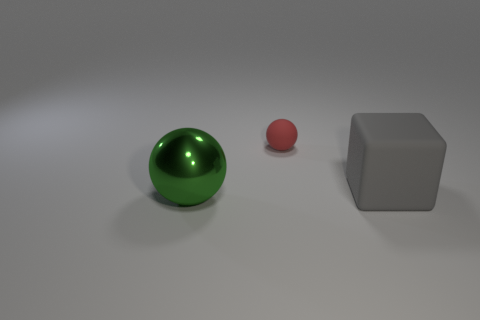Add 1 brown cylinders. How many objects exist? 4 Subtract all balls. How many objects are left? 1 Subtract all gray matte objects. Subtract all red rubber balls. How many objects are left? 1 Add 2 metal spheres. How many metal spheres are left? 3 Add 3 tiny matte spheres. How many tiny matte spheres exist? 4 Subtract 0 blue spheres. How many objects are left? 3 